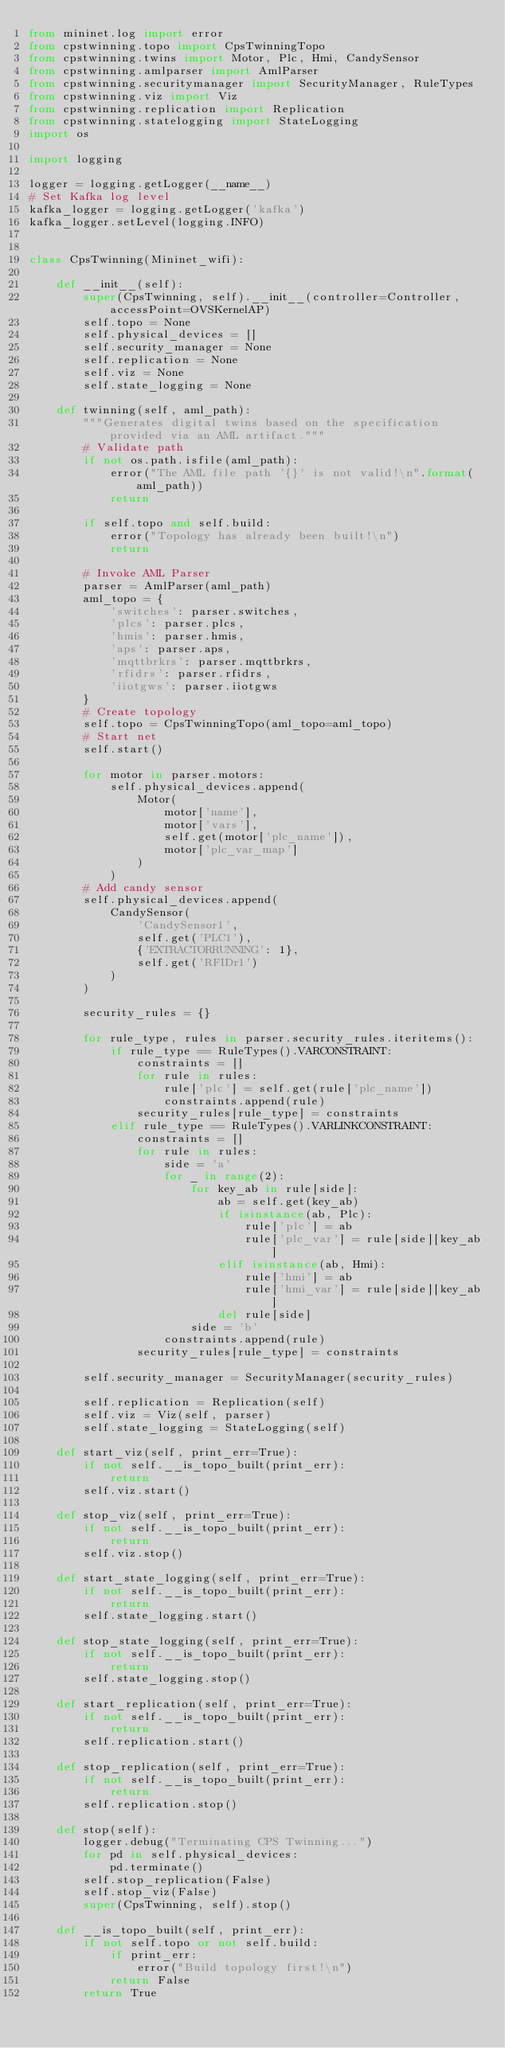<code> <loc_0><loc_0><loc_500><loc_500><_Python_>from mininet.log import error
from cpstwinning.topo import CpsTwinningTopo
from cpstwinning.twins import Motor, Plc, Hmi, CandySensor
from cpstwinning.amlparser import AmlParser
from cpstwinning.securitymanager import SecurityManager, RuleTypes
from cpstwinning.viz import Viz
from cpstwinning.replication import Replication
from cpstwinning.statelogging import StateLogging
import os

import logging

logger = logging.getLogger(__name__)
# Set Kafka log level
kafka_logger = logging.getLogger('kafka')
kafka_logger.setLevel(logging.INFO)


class CpsTwinning(Mininet_wifi):

    def __init__(self):
        super(CpsTwinning, self).__init__(controller=Controller, accessPoint=OVSKernelAP)
        self.topo = None
        self.physical_devices = []
        self.security_manager = None
        self.replication = None
        self.viz = None
        self.state_logging = None

    def twinning(self, aml_path):
        """Generates digital twins based on the specification provided via an AML artifact."""
        # Validate path
        if not os.path.isfile(aml_path):
            error("The AML file path '{}' is not valid!\n".format(aml_path))
            return

        if self.topo and self.build:
            error("Topology has already been built!\n")
            return

        # Invoke AML Parser
        parser = AmlParser(aml_path)
        aml_topo = {
            'switches': parser.switches,
            'plcs': parser.plcs,
            'hmis': parser.hmis,
            'aps': parser.aps,
            'mqttbrkrs': parser.mqttbrkrs,
            'rfidrs': parser.rfidrs,
            'iiotgws': parser.iiotgws
        }
        # Create topology
        self.topo = CpsTwinningTopo(aml_topo=aml_topo)
        # Start net
        self.start()

        for motor in parser.motors:
            self.physical_devices.append(
                Motor(
                    motor['name'],
                    motor['vars'],
                    self.get(motor['plc_name']),
                    motor['plc_var_map']
                )
            )
        # Add candy sensor
        self.physical_devices.append(
            CandySensor(
                'CandySensor1',
                self.get('PLC1'),
                {'EXTRACTORRUNNING': 1},
                self.get('RFIDr1')
            )
        )

        security_rules = {}

        for rule_type, rules in parser.security_rules.iteritems():
            if rule_type == RuleTypes().VARCONSTRAINT:
                constraints = []
                for rule in rules:
                    rule['plc'] = self.get(rule['plc_name'])
                    constraints.append(rule)
                security_rules[rule_type] = constraints
            elif rule_type == RuleTypes().VARLINKCONSTRAINT:
                constraints = []
                for rule in rules:
                    side = 'a'
                    for _ in range(2):
                        for key_ab in rule[side]:
                            ab = self.get(key_ab)
                            if isinstance(ab, Plc):
                                rule['plc'] = ab
                                rule['plc_var'] = rule[side][key_ab]
                            elif isinstance(ab, Hmi):
                                rule['hmi'] = ab
                                rule['hmi_var'] = rule[side][key_ab]
                            del rule[side]
                        side = 'b'
                    constraints.append(rule)
                security_rules[rule_type] = constraints

        self.security_manager = SecurityManager(security_rules)

        self.replication = Replication(self)
        self.viz = Viz(self, parser)
        self.state_logging = StateLogging(self)

    def start_viz(self, print_err=True):
        if not self.__is_topo_built(print_err):
            return
        self.viz.start()

    def stop_viz(self, print_err=True):
        if not self.__is_topo_built(print_err):
            return
        self.viz.stop()

    def start_state_logging(self, print_err=True):
        if not self.__is_topo_built(print_err):
            return
        self.state_logging.start()

    def stop_state_logging(self, print_err=True):
        if not self.__is_topo_built(print_err):
            return
        self.state_logging.stop()

    def start_replication(self, print_err=True):
        if not self.__is_topo_built(print_err):
            return
        self.replication.start()

    def stop_replication(self, print_err=True):
        if not self.__is_topo_built(print_err):
            return
        self.replication.stop()

    def stop(self):
        logger.debug("Terminating CPS Twinning...")
        for pd in self.physical_devices:
            pd.terminate()
        self.stop_replication(False)
        self.stop_viz(False)
        super(CpsTwinning, self).stop()

    def __is_topo_built(self, print_err):
        if not self.topo or not self.build:
            if print_err:
                error("Build topology first!\n")
            return False
        return True
</code> 